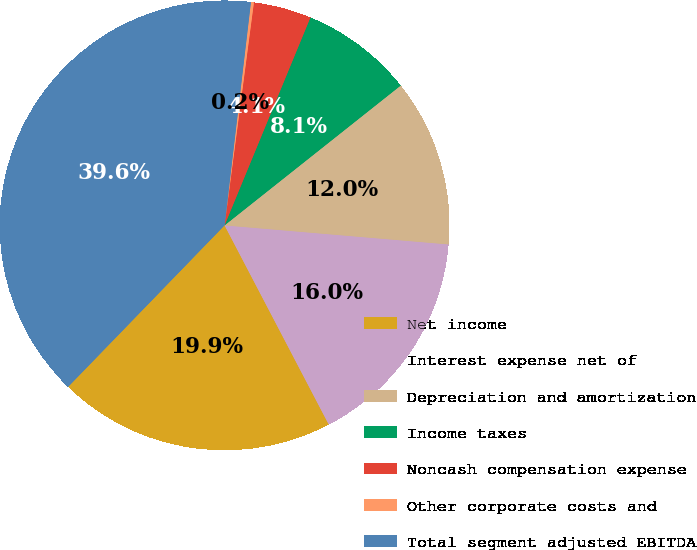Convert chart to OTSL. <chart><loc_0><loc_0><loc_500><loc_500><pie_chart><fcel>Net income<fcel>Interest expense net of<fcel>Depreciation and amortization<fcel>Income taxes<fcel>Noncash compensation expense<fcel>Other corporate costs and<fcel>Total segment adjusted EBITDA<nl><fcel>19.92%<fcel>15.98%<fcel>12.03%<fcel>8.09%<fcel>4.15%<fcel>0.21%<fcel>39.63%<nl></chart> 